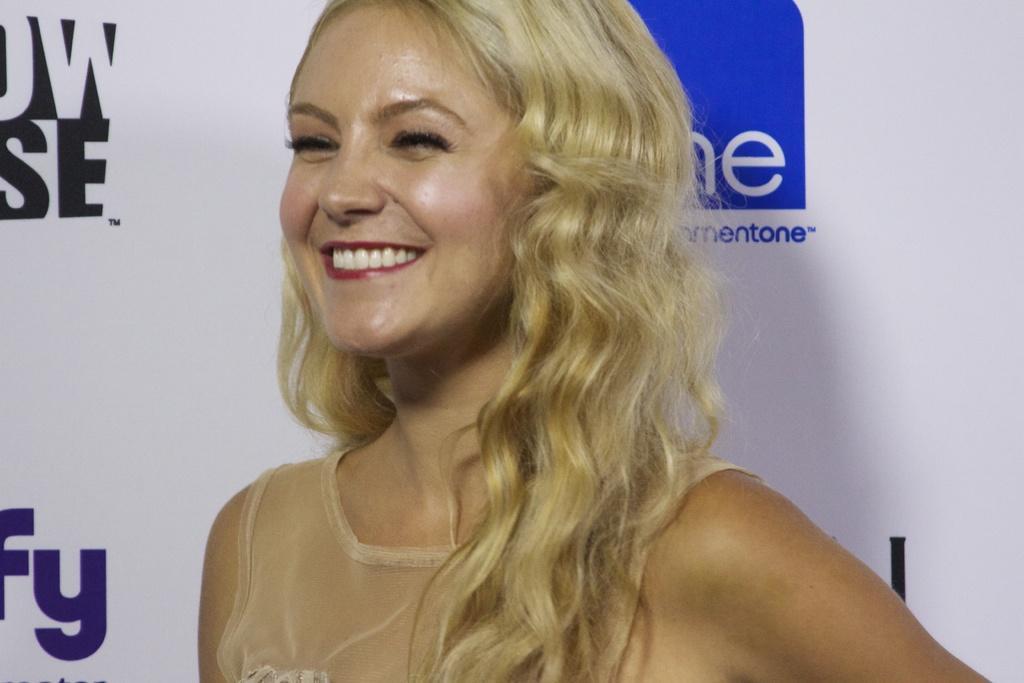Describe this image in one or two sentences. In this picture there is a woman standing and smiling and there is a banner behind her which has something written on it. 